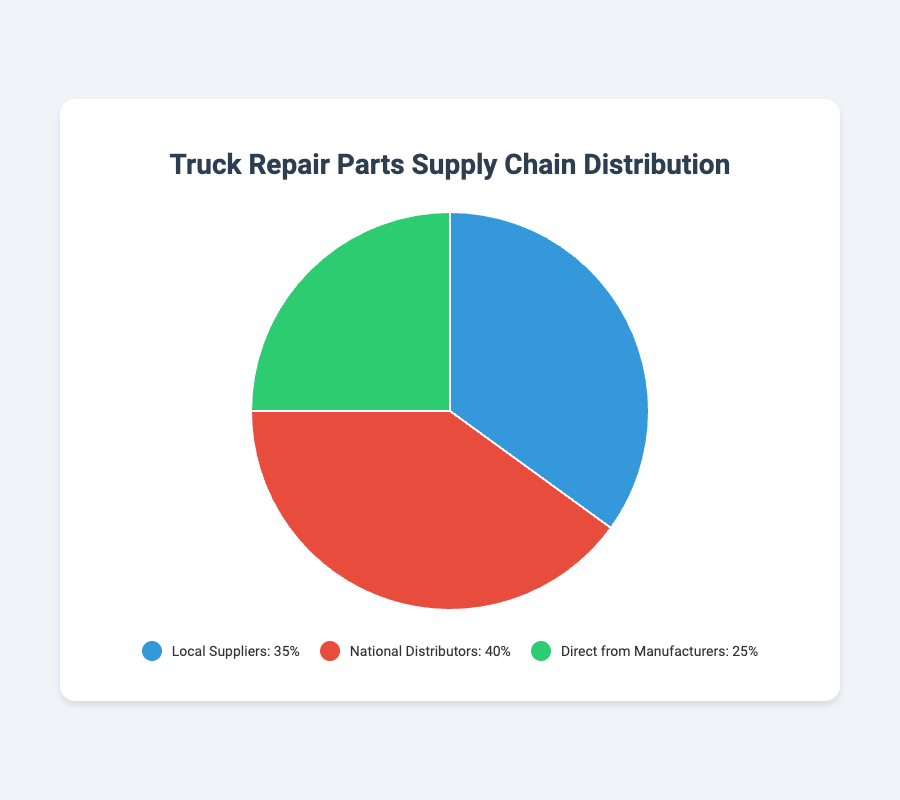What percentage of parts come from Local Suppliers and Direct from Manufacturers combined? To find this, add the percentage share of Local Suppliers (35%) and Direct from Manufacturers (25%): 35% + 25% = 60%
Answer: 60% Which source has the smallest share in the supply chain? Compare the percentages of all sources: Local Suppliers (35%), National Distributors (40%), and Direct from Manufacturers (25%). The smallest share is 25%.
Answer: Direct from Manufacturers How much larger is the share of National Distributors compared to Direct from Manufacturers? Subtract the percentage share of Direct from Manufacturers (25%) from National Distributors (40%): 40% - 25% = 15%
Answer: 15% Which source of the parts supply chain is represented by the green color in the pie chart? The green color is associated with the segment that represents a 25% share, which corresponds to Direct from Manufacturers.
Answer: Direct from Manufacturers Which source has the highest share in the supply chain? Compare the percentages of all sources: Local Suppliers (35%), National Distributors (40%), and Direct from Manufacturers (25%). The highest share is 40%.
Answer: National Distributors Is the share of National Distributors greater than the combined share of Local Suppliers and Direct from Manufacturers? Calculate the combined share of Local Suppliers and Direct from Manufacturers: 35% + 25% = 60%. The share of National Distributors is 40%, which is less than 60%.
Answer: No What is the average share percentage of all three sources in the supply chain? Add the percentages of all sources and divide by the number of sources: (35% + 40% + 25%) / 3 = 100% / 3 ≈ 33.33%
Answer: 33.33% Among all sources, which one has the second highest share in the supply chain? List the percentages in descending order: 40% (National Distributors), 35% (Local Suppliers), and 25% (Direct from Manufacturers). The second highest is 35%.
Answer: Local Suppliers 